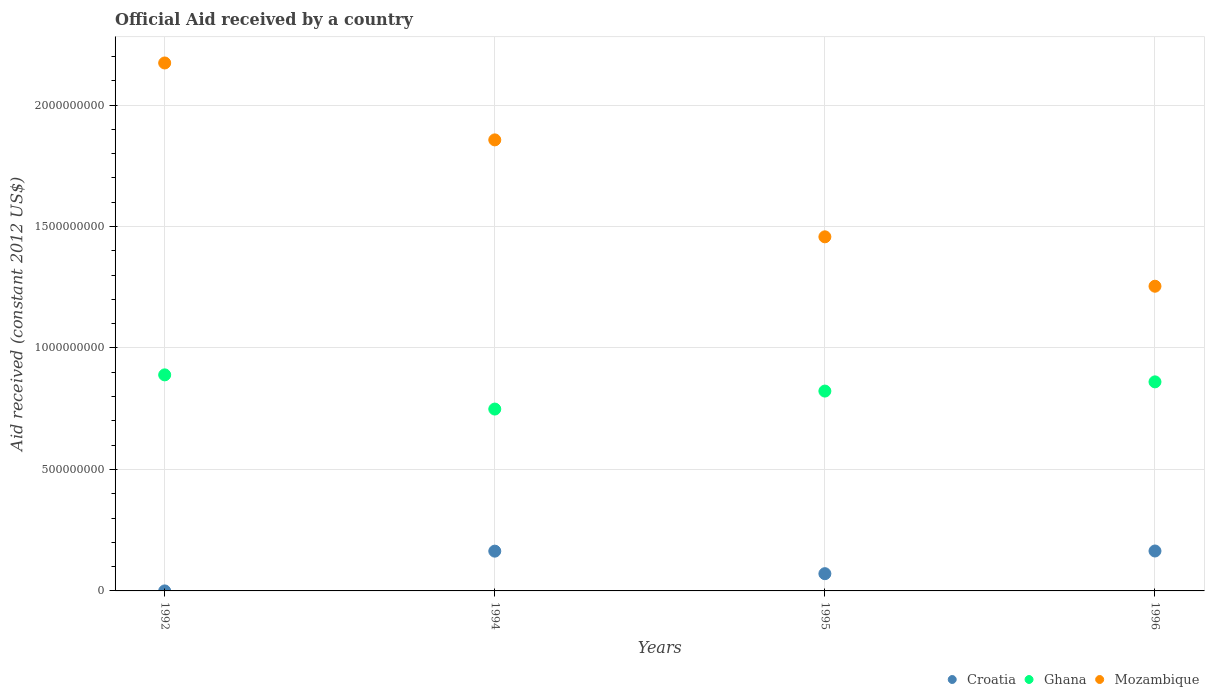How many different coloured dotlines are there?
Your answer should be compact. 3. What is the net official aid received in Ghana in 1992?
Keep it short and to the point. 8.89e+08. Across all years, what is the maximum net official aid received in Ghana?
Provide a short and direct response. 8.89e+08. Across all years, what is the minimum net official aid received in Croatia?
Keep it short and to the point. 2.00e+04. In which year was the net official aid received in Croatia minimum?
Offer a terse response. 1992. What is the total net official aid received in Ghana in the graph?
Provide a short and direct response. 3.32e+09. What is the difference between the net official aid received in Croatia in 1992 and that in 1995?
Provide a short and direct response. -7.10e+07. What is the difference between the net official aid received in Ghana in 1992 and the net official aid received in Mozambique in 1996?
Ensure brevity in your answer.  -3.65e+08. What is the average net official aid received in Ghana per year?
Offer a terse response. 8.30e+08. In the year 1994, what is the difference between the net official aid received in Ghana and net official aid received in Mozambique?
Your answer should be compact. -1.11e+09. In how many years, is the net official aid received in Ghana greater than 400000000 US$?
Your answer should be compact. 4. What is the ratio of the net official aid received in Ghana in 1992 to that in 1994?
Your answer should be very brief. 1.19. What is the difference between the highest and the second highest net official aid received in Croatia?
Keep it short and to the point. 6.20e+05. What is the difference between the highest and the lowest net official aid received in Mozambique?
Provide a short and direct response. 9.19e+08. In how many years, is the net official aid received in Mozambique greater than the average net official aid received in Mozambique taken over all years?
Make the answer very short. 2. Does the net official aid received in Croatia monotonically increase over the years?
Offer a very short reply. No. Is the net official aid received in Ghana strictly less than the net official aid received in Mozambique over the years?
Offer a very short reply. Yes. What is the difference between two consecutive major ticks on the Y-axis?
Keep it short and to the point. 5.00e+08. Are the values on the major ticks of Y-axis written in scientific E-notation?
Provide a short and direct response. No. Does the graph contain any zero values?
Provide a short and direct response. No. Where does the legend appear in the graph?
Your response must be concise. Bottom right. What is the title of the graph?
Offer a terse response. Official Aid received by a country. Does "Philippines" appear as one of the legend labels in the graph?
Give a very brief answer. No. What is the label or title of the X-axis?
Keep it short and to the point. Years. What is the label or title of the Y-axis?
Give a very brief answer. Aid received (constant 2012 US$). What is the Aid received (constant 2012 US$) of Croatia in 1992?
Give a very brief answer. 2.00e+04. What is the Aid received (constant 2012 US$) in Ghana in 1992?
Give a very brief answer. 8.89e+08. What is the Aid received (constant 2012 US$) in Mozambique in 1992?
Provide a short and direct response. 2.17e+09. What is the Aid received (constant 2012 US$) of Croatia in 1994?
Your answer should be compact. 1.64e+08. What is the Aid received (constant 2012 US$) in Ghana in 1994?
Your response must be concise. 7.49e+08. What is the Aid received (constant 2012 US$) of Mozambique in 1994?
Provide a short and direct response. 1.86e+09. What is the Aid received (constant 2012 US$) of Croatia in 1995?
Offer a very short reply. 7.10e+07. What is the Aid received (constant 2012 US$) in Ghana in 1995?
Your answer should be very brief. 8.23e+08. What is the Aid received (constant 2012 US$) of Mozambique in 1995?
Give a very brief answer. 1.46e+09. What is the Aid received (constant 2012 US$) of Croatia in 1996?
Your answer should be very brief. 1.64e+08. What is the Aid received (constant 2012 US$) of Ghana in 1996?
Offer a very short reply. 8.61e+08. What is the Aid received (constant 2012 US$) in Mozambique in 1996?
Offer a terse response. 1.25e+09. Across all years, what is the maximum Aid received (constant 2012 US$) of Croatia?
Offer a terse response. 1.64e+08. Across all years, what is the maximum Aid received (constant 2012 US$) of Ghana?
Ensure brevity in your answer.  8.89e+08. Across all years, what is the maximum Aid received (constant 2012 US$) of Mozambique?
Keep it short and to the point. 2.17e+09. Across all years, what is the minimum Aid received (constant 2012 US$) in Croatia?
Keep it short and to the point. 2.00e+04. Across all years, what is the minimum Aid received (constant 2012 US$) of Ghana?
Provide a succinct answer. 7.49e+08. Across all years, what is the minimum Aid received (constant 2012 US$) of Mozambique?
Ensure brevity in your answer.  1.25e+09. What is the total Aid received (constant 2012 US$) in Croatia in the graph?
Ensure brevity in your answer.  3.99e+08. What is the total Aid received (constant 2012 US$) of Ghana in the graph?
Provide a short and direct response. 3.32e+09. What is the total Aid received (constant 2012 US$) of Mozambique in the graph?
Your answer should be very brief. 6.74e+09. What is the difference between the Aid received (constant 2012 US$) of Croatia in 1992 and that in 1994?
Your response must be concise. -1.64e+08. What is the difference between the Aid received (constant 2012 US$) of Ghana in 1992 and that in 1994?
Your response must be concise. 1.41e+08. What is the difference between the Aid received (constant 2012 US$) in Mozambique in 1992 and that in 1994?
Ensure brevity in your answer.  3.17e+08. What is the difference between the Aid received (constant 2012 US$) in Croatia in 1992 and that in 1995?
Your answer should be very brief. -7.10e+07. What is the difference between the Aid received (constant 2012 US$) of Ghana in 1992 and that in 1995?
Ensure brevity in your answer.  6.67e+07. What is the difference between the Aid received (constant 2012 US$) in Mozambique in 1992 and that in 1995?
Offer a very short reply. 7.16e+08. What is the difference between the Aid received (constant 2012 US$) in Croatia in 1992 and that in 1996?
Offer a very short reply. -1.64e+08. What is the difference between the Aid received (constant 2012 US$) in Ghana in 1992 and that in 1996?
Provide a succinct answer. 2.88e+07. What is the difference between the Aid received (constant 2012 US$) in Mozambique in 1992 and that in 1996?
Provide a short and direct response. 9.19e+08. What is the difference between the Aid received (constant 2012 US$) of Croatia in 1994 and that in 1995?
Ensure brevity in your answer.  9.27e+07. What is the difference between the Aid received (constant 2012 US$) of Ghana in 1994 and that in 1995?
Offer a very short reply. -7.40e+07. What is the difference between the Aid received (constant 2012 US$) in Mozambique in 1994 and that in 1995?
Offer a terse response. 3.99e+08. What is the difference between the Aid received (constant 2012 US$) of Croatia in 1994 and that in 1996?
Your answer should be very brief. -6.20e+05. What is the difference between the Aid received (constant 2012 US$) of Ghana in 1994 and that in 1996?
Your response must be concise. -1.12e+08. What is the difference between the Aid received (constant 2012 US$) in Mozambique in 1994 and that in 1996?
Your response must be concise. 6.02e+08. What is the difference between the Aid received (constant 2012 US$) of Croatia in 1995 and that in 1996?
Keep it short and to the point. -9.34e+07. What is the difference between the Aid received (constant 2012 US$) in Ghana in 1995 and that in 1996?
Keep it short and to the point. -3.79e+07. What is the difference between the Aid received (constant 2012 US$) of Mozambique in 1995 and that in 1996?
Make the answer very short. 2.03e+08. What is the difference between the Aid received (constant 2012 US$) of Croatia in 1992 and the Aid received (constant 2012 US$) of Ghana in 1994?
Keep it short and to the point. -7.49e+08. What is the difference between the Aid received (constant 2012 US$) in Croatia in 1992 and the Aid received (constant 2012 US$) in Mozambique in 1994?
Make the answer very short. -1.86e+09. What is the difference between the Aid received (constant 2012 US$) in Ghana in 1992 and the Aid received (constant 2012 US$) in Mozambique in 1994?
Provide a succinct answer. -9.67e+08. What is the difference between the Aid received (constant 2012 US$) of Croatia in 1992 and the Aid received (constant 2012 US$) of Ghana in 1995?
Offer a very short reply. -8.23e+08. What is the difference between the Aid received (constant 2012 US$) in Croatia in 1992 and the Aid received (constant 2012 US$) in Mozambique in 1995?
Your answer should be very brief. -1.46e+09. What is the difference between the Aid received (constant 2012 US$) in Ghana in 1992 and the Aid received (constant 2012 US$) in Mozambique in 1995?
Give a very brief answer. -5.68e+08. What is the difference between the Aid received (constant 2012 US$) in Croatia in 1992 and the Aid received (constant 2012 US$) in Ghana in 1996?
Offer a very short reply. -8.61e+08. What is the difference between the Aid received (constant 2012 US$) in Croatia in 1992 and the Aid received (constant 2012 US$) in Mozambique in 1996?
Keep it short and to the point. -1.25e+09. What is the difference between the Aid received (constant 2012 US$) of Ghana in 1992 and the Aid received (constant 2012 US$) of Mozambique in 1996?
Provide a succinct answer. -3.65e+08. What is the difference between the Aid received (constant 2012 US$) in Croatia in 1994 and the Aid received (constant 2012 US$) in Ghana in 1995?
Your answer should be compact. -6.59e+08. What is the difference between the Aid received (constant 2012 US$) of Croatia in 1994 and the Aid received (constant 2012 US$) of Mozambique in 1995?
Offer a terse response. -1.29e+09. What is the difference between the Aid received (constant 2012 US$) in Ghana in 1994 and the Aid received (constant 2012 US$) in Mozambique in 1995?
Ensure brevity in your answer.  -7.09e+08. What is the difference between the Aid received (constant 2012 US$) in Croatia in 1994 and the Aid received (constant 2012 US$) in Ghana in 1996?
Your answer should be very brief. -6.97e+08. What is the difference between the Aid received (constant 2012 US$) in Croatia in 1994 and the Aid received (constant 2012 US$) in Mozambique in 1996?
Your response must be concise. -1.09e+09. What is the difference between the Aid received (constant 2012 US$) of Ghana in 1994 and the Aid received (constant 2012 US$) of Mozambique in 1996?
Provide a short and direct response. -5.06e+08. What is the difference between the Aid received (constant 2012 US$) of Croatia in 1995 and the Aid received (constant 2012 US$) of Ghana in 1996?
Keep it short and to the point. -7.90e+08. What is the difference between the Aid received (constant 2012 US$) of Croatia in 1995 and the Aid received (constant 2012 US$) of Mozambique in 1996?
Offer a very short reply. -1.18e+09. What is the difference between the Aid received (constant 2012 US$) in Ghana in 1995 and the Aid received (constant 2012 US$) in Mozambique in 1996?
Provide a short and direct response. -4.32e+08. What is the average Aid received (constant 2012 US$) in Croatia per year?
Offer a terse response. 9.98e+07. What is the average Aid received (constant 2012 US$) of Ghana per year?
Keep it short and to the point. 8.30e+08. What is the average Aid received (constant 2012 US$) in Mozambique per year?
Provide a short and direct response. 1.69e+09. In the year 1992, what is the difference between the Aid received (constant 2012 US$) in Croatia and Aid received (constant 2012 US$) in Ghana?
Make the answer very short. -8.89e+08. In the year 1992, what is the difference between the Aid received (constant 2012 US$) in Croatia and Aid received (constant 2012 US$) in Mozambique?
Give a very brief answer. -2.17e+09. In the year 1992, what is the difference between the Aid received (constant 2012 US$) of Ghana and Aid received (constant 2012 US$) of Mozambique?
Your answer should be compact. -1.28e+09. In the year 1994, what is the difference between the Aid received (constant 2012 US$) of Croatia and Aid received (constant 2012 US$) of Ghana?
Offer a terse response. -5.85e+08. In the year 1994, what is the difference between the Aid received (constant 2012 US$) of Croatia and Aid received (constant 2012 US$) of Mozambique?
Provide a succinct answer. -1.69e+09. In the year 1994, what is the difference between the Aid received (constant 2012 US$) in Ghana and Aid received (constant 2012 US$) in Mozambique?
Your answer should be compact. -1.11e+09. In the year 1995, what is the difference between the Aid received (constant 2012 US$) of Croatia and Aid received (constant 2012 US$) of Ghana?
Your response must be concise. -7.52e+08. In the year 1995, what is the difference between the Aid received (constant 2012 US$) of Croatia and Aid received (constant 2012 US$) of Mozambique?
Offer a very short reply. -1.39e+09. In the year 1995, what is the difference between the Aid received (constant 2012 US$) in Ghana and Aid received (constant 2012 US$) in Mozambique?
Provide a short and direct response. -6.35e+08. In the year 1996, what is the difference between the Aid received (constant 2012 US$) of Croatia and Aid received (constant 2012 US$) of Ghana?
Offer a terse response. -6.96e+08. In the year 1996, what is the difference between the Aid received (constant 2012 US$) in Croatia and Aid received (constant 2012 US$) in Mozambique?
Ensure brevity in your answer.  -1.09e+09. In the year 1996, what is the difference between the Aid received (constant 2012 US$) of Ghana and Aid received (constant 2012 US$) of Mozambique?
Provide a succinct answer. -3.94e+08. What is the ratio of the Aid received (constant 2012 US$) in Croatia in 1992 to that in 1994?
Ensure brevity in your answer.  0. What is the ratio of the Aid received (constant 2012 US$) of Ghana in 1992 to that in 1994?
Provide a succinct answer. 1.19. What is the ratio of the Aid received (constant 2012 US$) in Mozambique in 1992 to that in 1994?
Provide a succinct answer. 1.17. What is the ratio of the Aid received (constant 2012 US$) of Croatia in 1992 to that in 1995?
Keep it short and to the point. 0. What is the ratio of the Aid received (constant 2012 US$) of Ghana in 1992 to that in 1995?
Make the answer very short. 1.08. What is the ratio of the Aid received (constant 2012 US$) of Mozambique in 1992 to that in 1995?
Your answer should be compact. 1.49. What is the ratio of the Aid received (constant 2012 US$) in Croatia in 1992 to that in 1996?
Provide a short and direct response. 0. What is the ratio of the Aid received (constant 2012 US$) of Ghana in 1992 to that in 1996?
Provide a short and direct response. 1.03. What is the ratio of the Aid received (constant 2012 US$) of Mozambique in 1992 to that in 1996?
Your answer should be compact. 1.73. What is the ratio of the Aid received (constant 2012 US$) in Croatia in 1994 to that in 1995?
Provide a short and direct response. 2.31. What is the ratio of the Aid received (constant 2012 US$) of Ghana in 1994 to that in 1995?
Keep it short and to the point. 0.91. What is the ratio of the Aid received (constant 2012 US$) of Mozambique in 1994 to that in 1995?
Ensure brevity in your answer.  1.27. What is the ratio of the Aid received (constant 2012 US$) of Croatia in 1994 to that in 1996?
Give a very brief answer. 1. What is the ratio of the Aid received (constant 2012 US$) of Ghana in 1994 to that in 1996?
Give a very brief answer. 0.87. What is the ratio of the Aid received (constant 2012 US$) in Mozambique in 1994 to that in 1996?
Give a very brief answer. 1.48. What is the ratio of the Aid received (constant 2012 US$) in Croatia in 1995 to that in 1996?
Make the answer very short. 0.43. What is the ratio of the Aid received (constant 2012 US$) in Ghana in 1995 to that in 1996?
Keep it short and to the point. 0.96. What is the ratio of the Aid received (constant 2012 US$) of Mozambique in 1995 to that in 1996?
Your response must be concise. 1.16. What is the difference between the highest and the second highest Aid received (constant 2012 US$) of Croatia?
Offer a very short reply. 6.20e+05. What is the difference between the highest and the second highest Aid received (constant 2012 US$) in Ghana?
Make the answer very short. 2.88e+07. What is the difference between the highest and the second highest Aid received (constant 2012 US$) in Mozambique?
Provide a short and direct response. 3.17e+08. What is the difference between the highest and the lowest Aid received (constant 2012 US$) of Croatia?
Make the answer very short. 1.64e+08. What is the difference between the highest and the lowest Aid received (constant 2012 US$) of Ghana?
Offer a terse response. 1.41e+08. What is the difference between the highest and the lowest Aid received (constant 2012 US$) in Mozambique?
Give a very brief answer. 9.19e+08. 